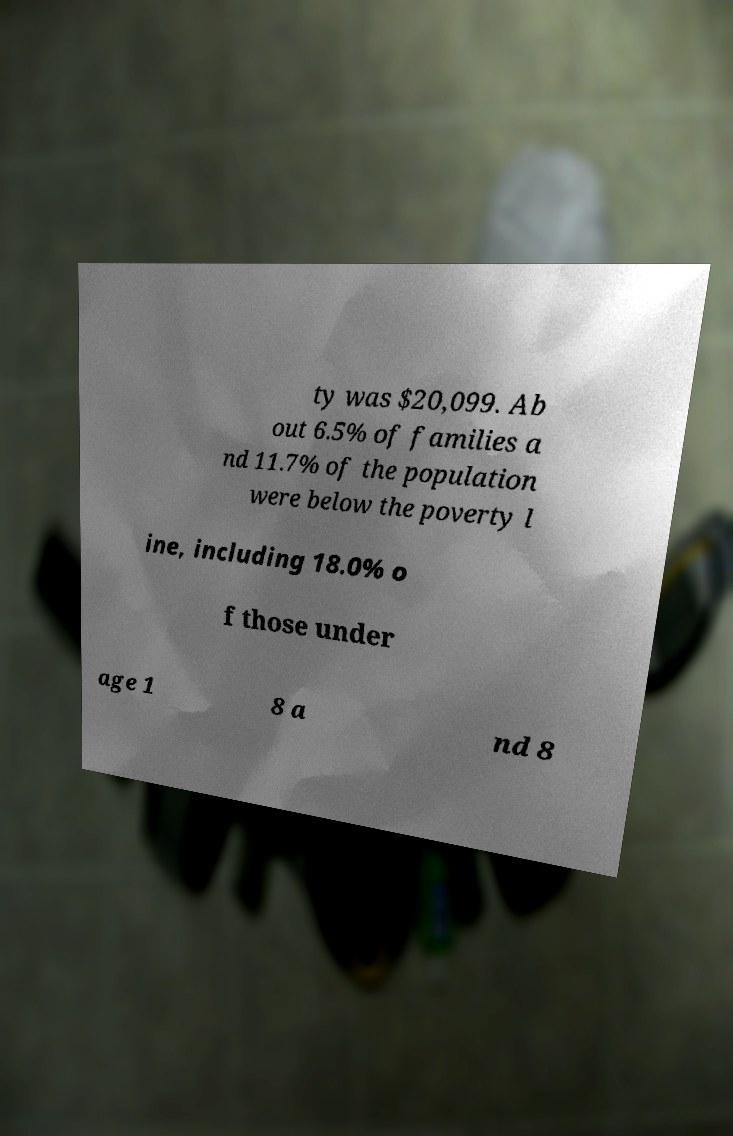What messages or text are displayed in this image? I need them in a readable, typed format. ty was $20,099. Ab out 6.5% of families a nd 11.7% of the population were below the poverty l ine, including 18.0% o f those under age 1 8 a nd 8 